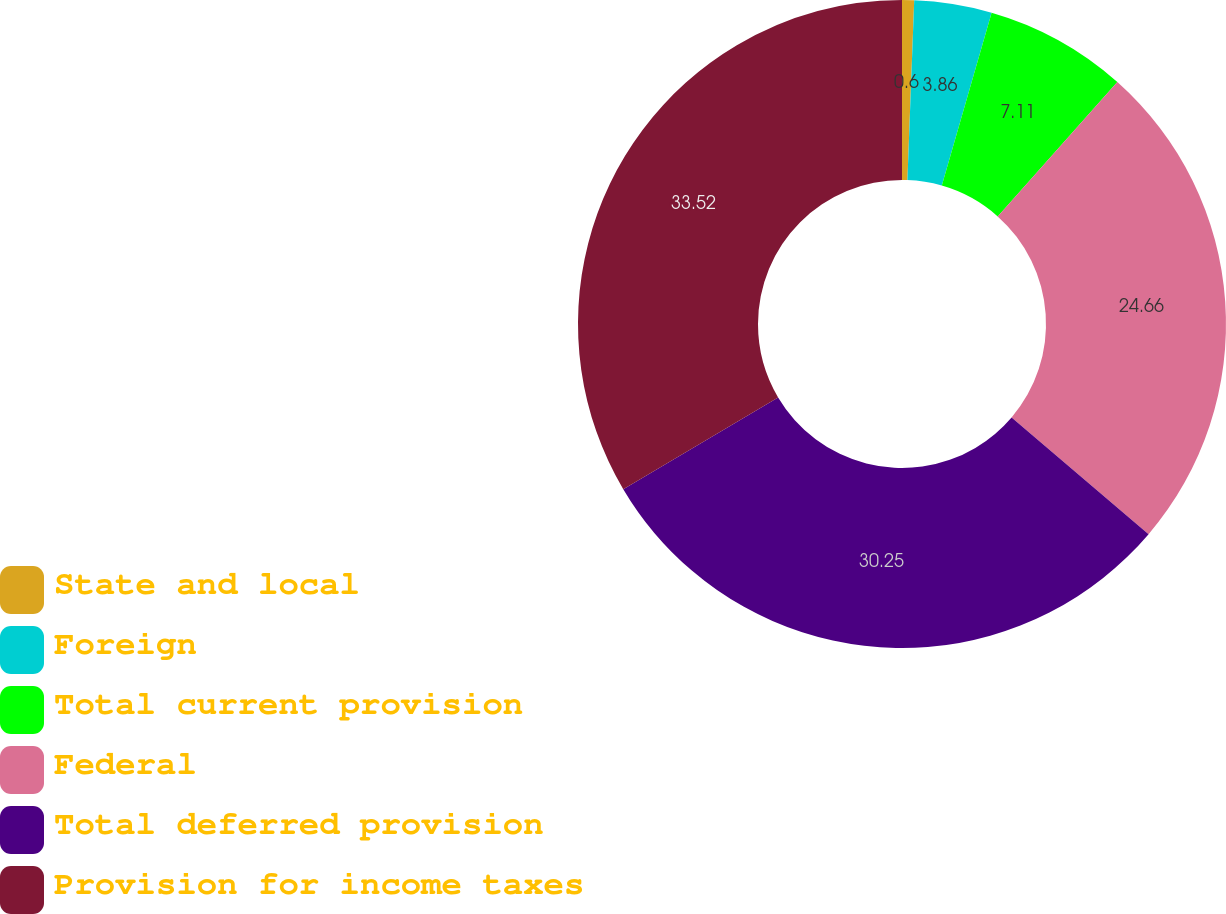Convert chart. <chart><loc_0><loc_0><loc_500><loc_500><pie_chart><fcel>State and local<fcel>Foreign<fcel>Total current provision<fcel>Federal<fcel>Total deferred provision<fcel>Provision for income taxes<nl><fcel>0.6%<fcel>3.86%<fcel>7.11%<fcel>24.66%<fcel>30.25%<fcel>33.51%<nl></chart> 